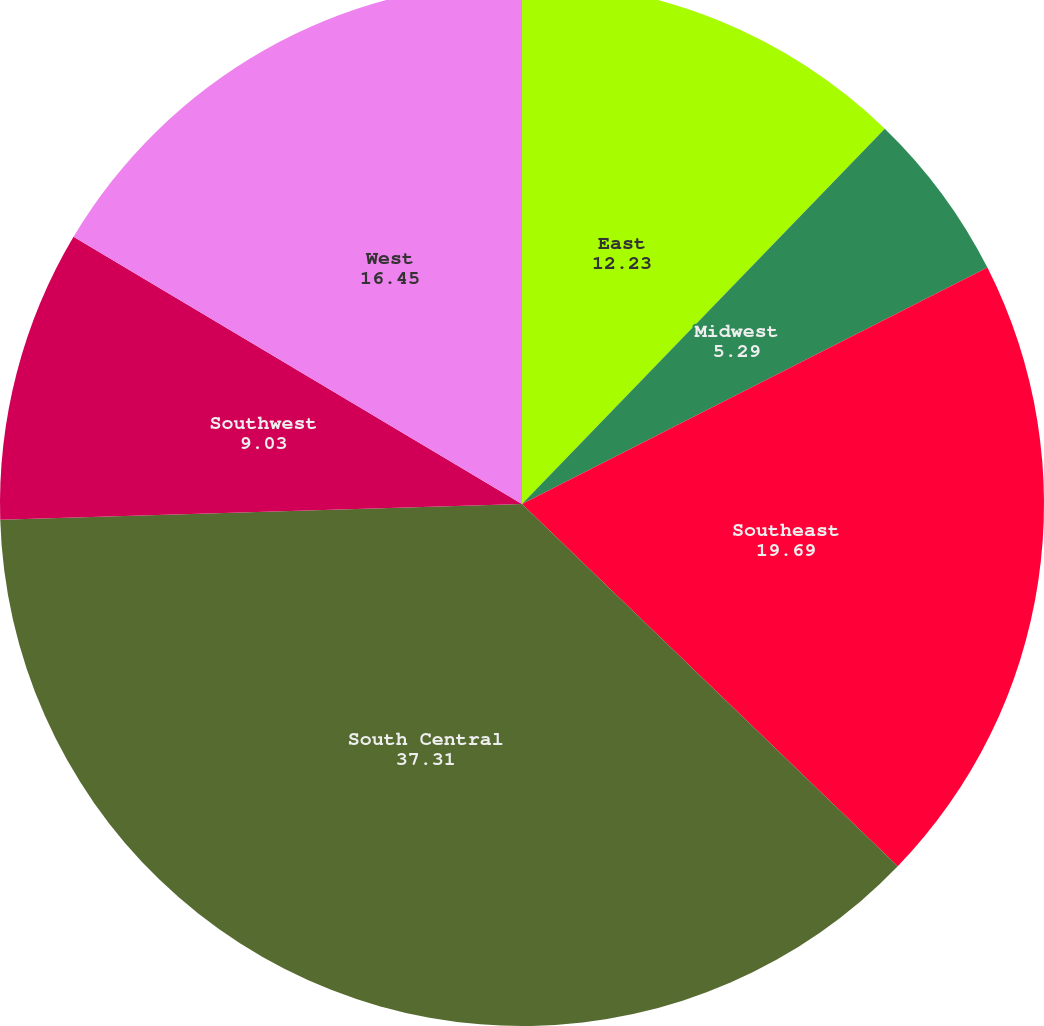<chart> <loc_0><loc_0><loc_500><loc_500><pie_chart><fcel>East<fcel>Midwest<fcel>Southeast<fcel>South Central<fcel>Southwest<fcel>West<nl><fcel>12.23%<fcel>5.29%<fcel>19.69%<fcel>37.31%<fcel>9.03%<fcel>16.45%<nl></chart> 